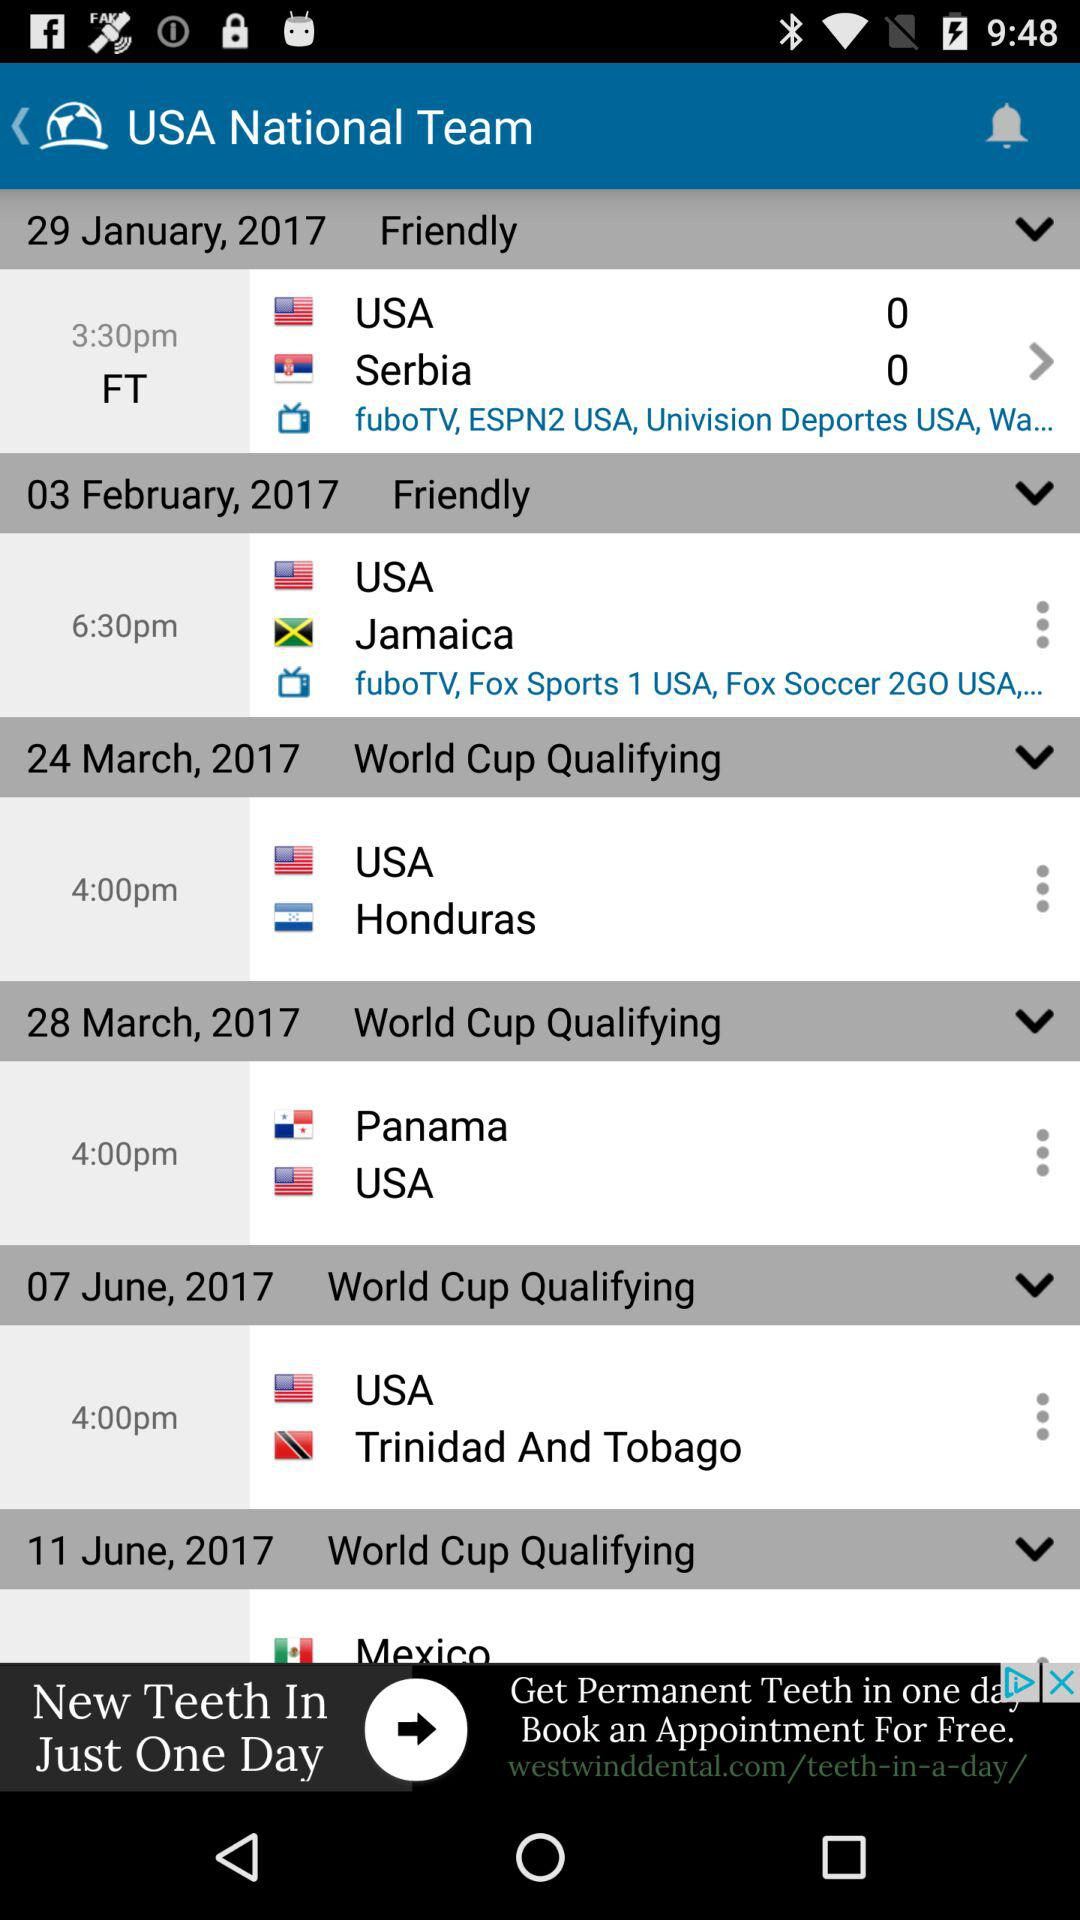On which TV channel will the friendly match between the USA and Jamaica be telecast? The channels are fuboTV, Fox Sports 1 USA and Fox Soccer 2GO USA. 